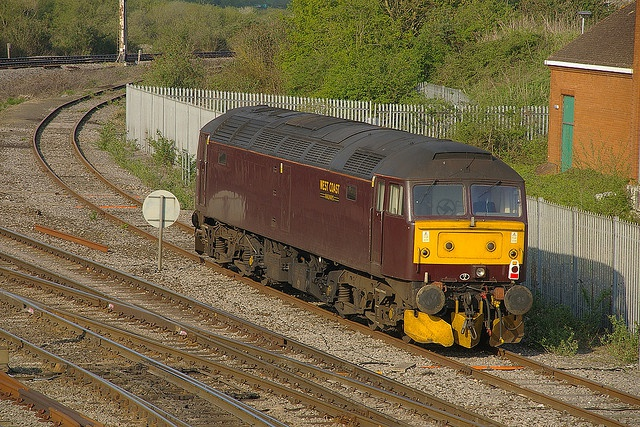Describe the objects in this image and their specific colors. I can see a train in olive, gray, maroon, and black tones in this image. 